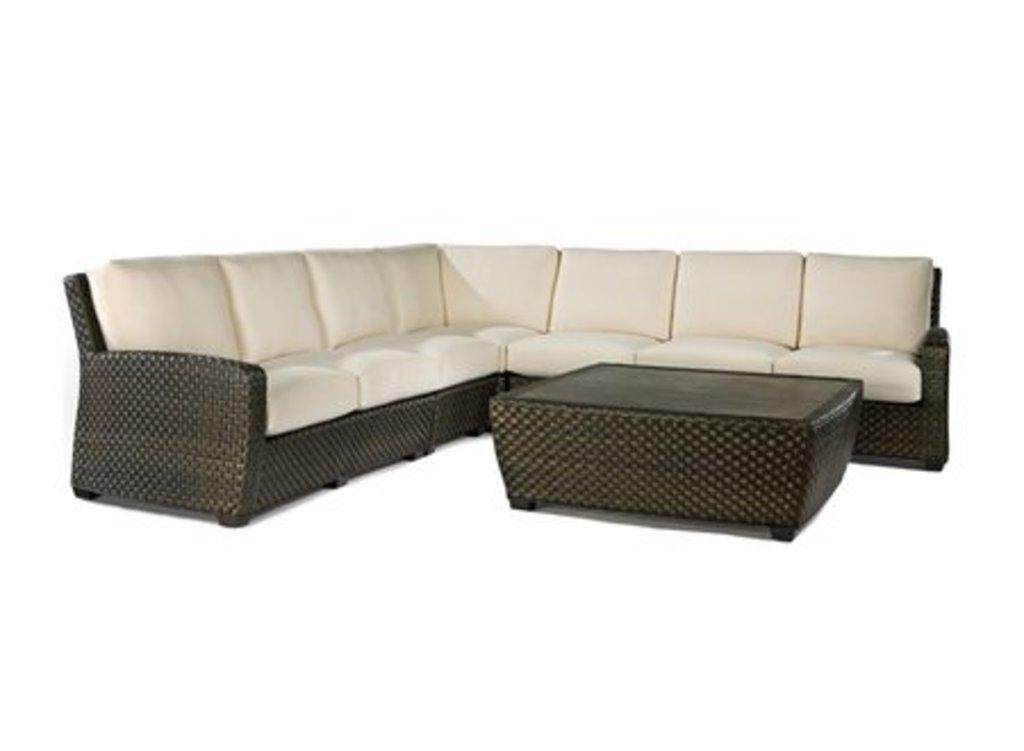What color is the sofa in the image? The sofa in the image is black and white. What color is the table in the image? The table in the image is black. What color is the background of the image? The background of the image is white. Can you tell me how the river affects the voyage in the image? There is no river or voyage present in the image; it features a black and white sofa and a black table against a white background. What type of pollution is visible in the image? There is no pollution visible in the image; it only contains a sofa, a table, and a white background. 